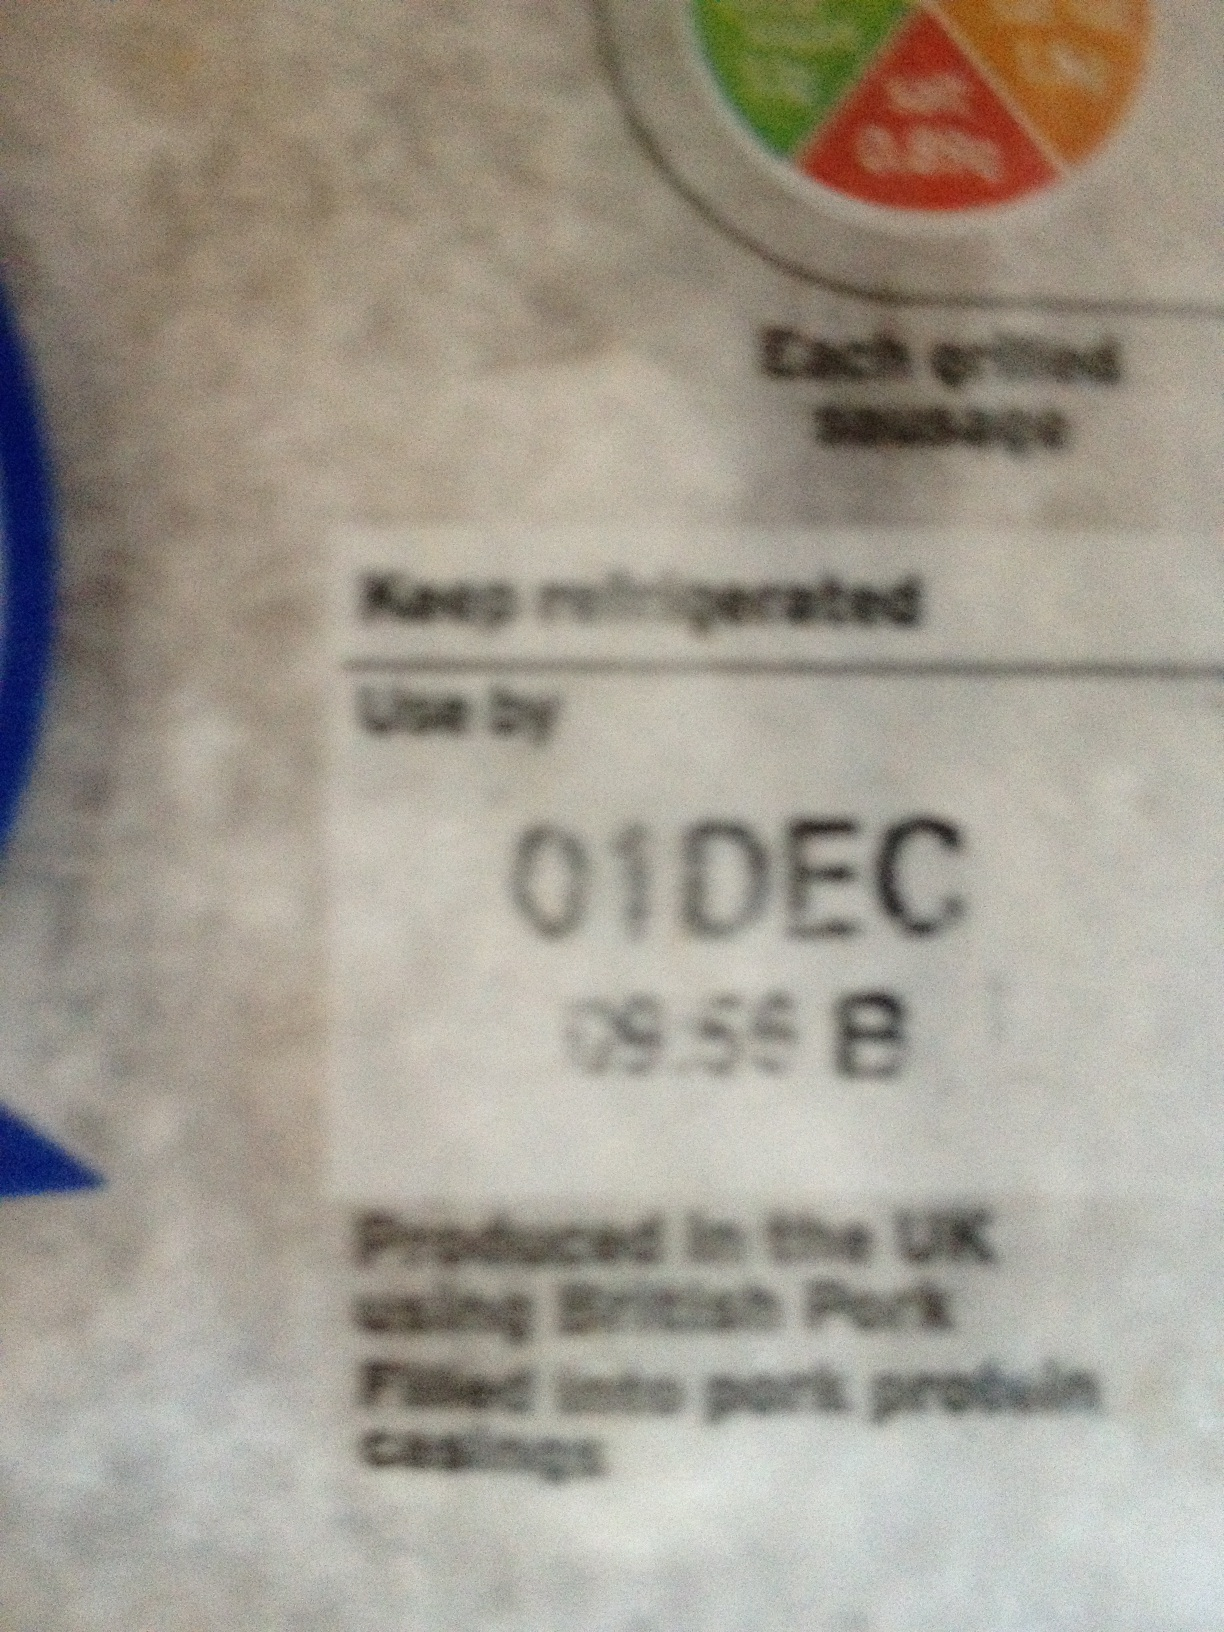Why do food packages often have these color-coded labels? The color-coded labels on food packages are often used to provide quick nutritional information. They help consumers easily identify the nutritional content of the food, such as fat, sugar, salt, and calorie levels, using a color system where green generally indicates a healthier option, and red indicates a higher level of the nutrient. Can you tell me more about the benefits of using British Pork? Using British Pork can offer several benefits. It tends to support local farmers and the UK agriculture industry, ensuring that standards of animal welfare, traceability, and food quality are maintained. Additionally, it can reduce the carbon footprint associated with transportation compared to importing pork from overseas. What other details on this label are important for consumers? In addition to the 'Use by' date and the origin of the pork, consumers should also pay attention to the storage instructions ('Keep refrigerated'), and any nutritional information to make informed dietary choices. The batch details ('09:55 B') are more relevant to the manufacturer but can also be useful to consumers if any recall or quality issues are notified. 